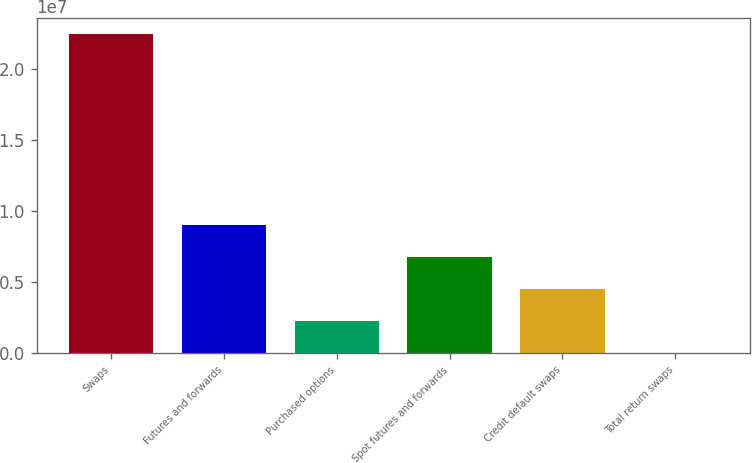<chart> <loc_0><loc_0><loc_500><loc_500><bar_chart><fcel>Swaps<fcel>Futures and forwards<fcel>Purchased options<fcel>Spot futures and forwards<fcel>Credit default swaps<fcel>Total return swaps<nl><fcel>2.24729e+07<fcel>8.99731e+06<fcel>2.25949e+06<fcel>6.75137e+06<fcel>4.50543e+06<fcel>13551<nl></chart> 